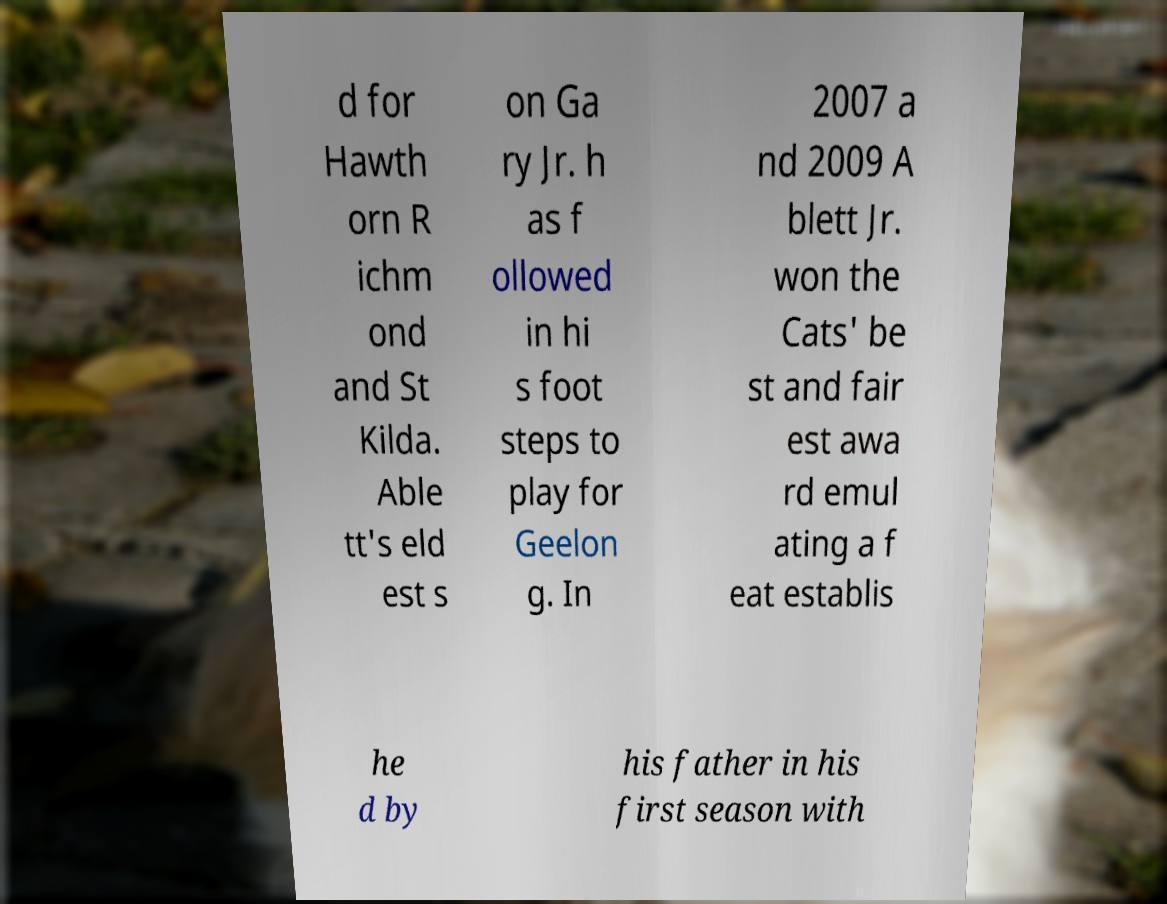I need the written content from this picture converted into text. Can you do that? d for Hawth orn R ichm ond and St Kilda. Able tt's eld est s on Ga ry Jr. h as f ollowed in hi s foot steps to play for Geelon g. In 2007 a nd 2009 A blett Jr. won the Cats' be st and fair est awa rd emul ating a f eat establis he d by his father in his first season with 